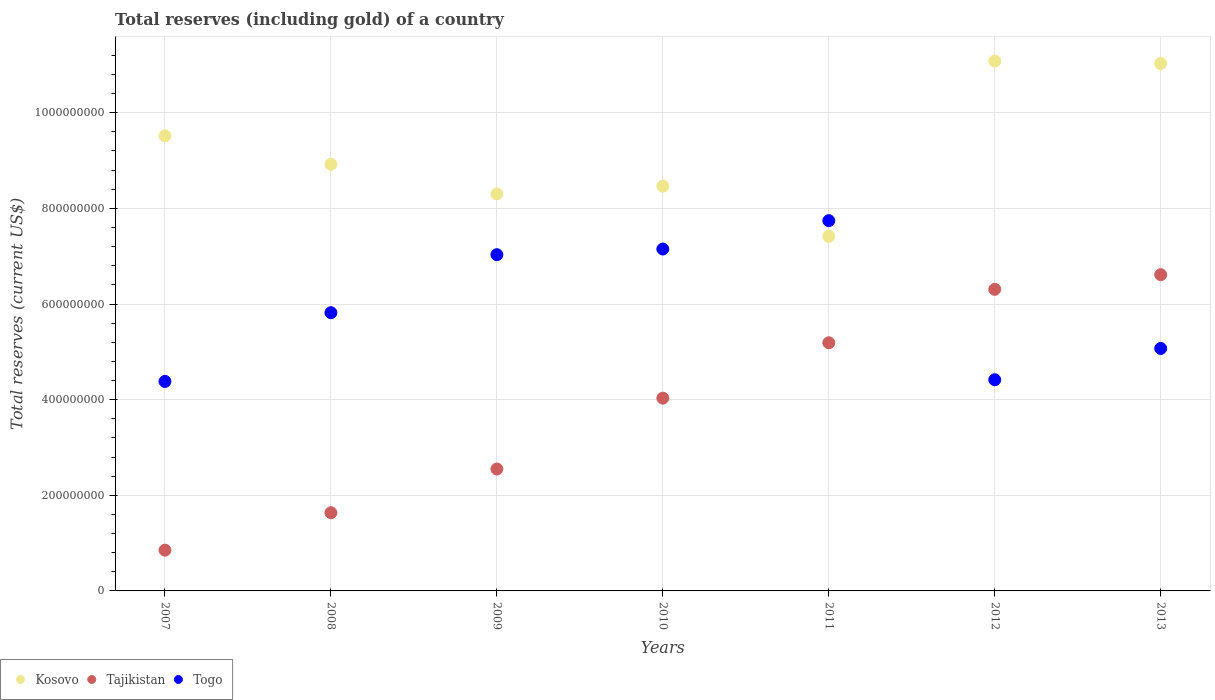How many different coloured dotlines are there?
Your answer should be very brief. 3. What is the total reserves (including gold) in Togo in 2008?
Keep it short and to the point. 5.82e+08. Across all years, what is the maximum total reserves (including gold) in Kosovo?
Ensure brevity in your answer.  1.11e+09. Across all years, what is the minimum total reserves (including gold) in Togo?
Your response must be concise. 4.38e+08. In which year was the total reserves (including gold) in Tajikistan maximum?
Your answer should be compact. 2013. What is the total total reserves (including gold) in Tajikistan in the graph?
Keep it short and to the point. 2.72e+09. What is the difference between the total reserves (including gold) in Tajikistan in 2010 and that in 2013?
Ensure brevity in your answer.  -2.58e+08. What is the difference between the total reserves (including gold) in Kosovo in 2011 and the total reserves (including gold) in Togo in 2010?
Your answer should be very brief. 2.66e+07. What is the average total reserves (including gold) in Togo per year?
Give a very brief answer. 5.94e+08. In the year 2012, what is the difference between the total reserves (including gold) in Kosovo and total reserves (including gold) in Togo?
Your answer should be compact. 6.66e+08. In how many years, is the total reserves (including gold) in Togo greater than 440000000 US$?
Offer a very short reply. 6. What is the ratio of the total reserves (including gold) in Tajikistan in 2008 to that in 2011?
Offer a very short reply. 0.32. Is the total reserves (including gold) in Tajikistan in 2007 less than that in 2011?
Offer a very short reply. Yes. What is the difference between the highest and the second highest total reserves (including gold) in Tajikistan?
Your answer should be compact. 3.06e+07. What is the difference between the highest and the lowest total reserves (including gold) in Tajikistan?
Your answer should be compact. 5.76e+08. Is the sum of the total reserves (including gold) in Kosovo in 2008 and 2009 greater than the maximum total reserves (including gold) in Tajikistan across all years?
Ensure brevity in your answer.  Yes. Is it the case that in every year, the sum of the total reserves (including gold) in Togo and total reserves (including gold) in Tajikistan  is greater than the total reserves (including gold) in Kosovo?
Make the answer very short. No. Does the total reserves (including gold) in Kosovo monotonically increase over the years?
Give a very brief answer. No. Is the total reserves (including gold) in Togo strictly less than the total reserves (including gold) in Kosovo over the years?
Give a very brief answer. No. How many dotlines are there?
Make the answer very short. 3. How many years are there in the graph?
Your answer should be very brief. 7. What is the difference between two consecutive major ticks on the Y-axis?
Ensure brevity in your answer.  2.00e+08. Does the graph contain any zero values?
Offer a terse response. No. Does the graph contain grids?
Ensure brevity in your answer.  Yes. What is the title of the graph?
Offer a terse response. Total reserves (including gold) of a country. What is the label or title of the Y-axis?
Your answer should be compact. Total reserves (current US$). What is the Total reserves (current US$) in Kosovo in 2007?
Ensure brevity in your answer.  9.52e+08. What is the Total reserves (current US$) in Tajikistan in 2007?
Keep it short and to the point. 8.52e+07. What is the Total reserves (current US$) of Togo in 2007?
Keep it short and to the point. 4.38e+08. What is the Total reserves (current US$) in Kosovo in 2008?
Give a very brief answer. 8.92e+08. What is the Total reserves (current US$) in Tajikistan in 2008?
Provide a succinct answer. 1.64e+08. What is the Total reserves (current US$) of Togo in 2008?
Ensure brevity in your answer.  5.82e+08. What is the Total reserves (current US$) in Kosovo in 2009?
Offer a very short reply. 8.30e+08. What is the Total reserves (current US$) of Tajikistan in 2009?
Your answer should be very brief. 2.55e+08. What is the Total reserves (current US$) in Togo in 2009?
Make the answer very short. 7.03e+08. What is the Total reserves (current US$) of Kosovo in 2010?
Offer a terse response. 8.46e+08. What is the Total reserves (current US$) in Tajikistan in 2010?
Provide a succinct answer. 4.03e+08. What is the Total reserves (current US$) of Togo in 2010?
Your answer should be compact. 7.15e+08. What is the Total reserves (current US$) of Kosovo in 2011?
Your response must be concise. 7.42e+08. What is the Total reserves (current US$) in Tajikistan in 2011?
Your response must be concise. 5.19e+08. What is the Total reserves (current US$) in Togo in 2011?
Make the answer very short. 7.74e+08. What is the Total reserves (current US$) in Kosovo in 2012?
Your answer should be very brief. 1.11e+09. What is the Total reserves (current US$) of Tajikistan in 2012?
Provide a succinct answer. 6.31e+08. What is the Total reserves (current US$) of Togo in 2012?
Your answer should be compact. 4.42e+08. What is the Total reserves (current US$) of Kosovo in 2013?
Keep it short and to the point. 1.10e+09. What is the Total reserves (current US$) in Tajikistan in 2013?
Make the answer very short. 6.61e+08. What is the Total reserves (current US$) of Togo in 2013?
Keep it short and to the point. 5.07e+08. Across all years, what is the maximum Total reserves (current US$) in Kosovo?
Make the answer very short. 1.11e+09. Across all years, what is the maximum Total reserves (current US$) in Tajikistan?
Provide a succinct answer. 6.61e+08. Across all years, what is the maximum Total reserves (current US$) of Togo?
Offer a very short reply. 7.74e+08. Across all years, what is the minimum Total reserves (current US$) in Kosovo?
Keep it short and to the point. 7.42e+08. Across all years, what is the minimum Total reserves (current US$) in Tajikistan?
Your answer should be compact. 8.52e+07. Across all years, what is the minimum Total reserves (current US$) of Togo?
Provide a short and direct response. 4.38e+08. What is the total Total reserves (current US$) in Kosovo in the graph?
Your response must be concise. 6.47e+09. What is the total Total reserves (current US$) of Tajikistan in the graph?
Make the answer very short. 2.72e+09. What is the total Total reserves (current US$) of Togo in the graph?
Ensure brevity in your answer.  4.16e+09. What is the difference between the Total reserves (current US$) in Kosovo in 2007 and that in 2008?
Your response must be concise. 5.97e+07. What is the difference between the Total reserves (current US$) in Tajikistan in 2007 and that in 2008?
Keep it short and to the point. -7.83e+07. What is the difference between the Total reserves (current US$) in Togo in 2007 and that in 2008?
Make the answer very short. -1.44e+08. What is the difference between the Total reserves (current US$) of Kosovo in 2007 and that in 2009?
Your response must be concise. 1.22e+08. What is the difference between the Total reserves (current US$) of Tajikistan in 2007 and that in 2009?
Your response must be concise. -1.70e+08. What is the difference between the Total reserves (current US$) in Togo in 2007 and that in 2009?
Your answer should be very brief. -2.65e+08. What is the difference between the Total reserves (current US$) in Kosovo in 2007 and that in 2010?
Make the answer very short. 1.05e+08. What is the difference between the Total reserves (current US$) in Tajikistan in 2007 and that in 2010?
Offer a terse response. -3.18e+08. What is the difference between the Total reserves (current US$) of Togo in 2007 and that in 2010?
Your answer should be compact. -2.77e+08. What is the difference between the Total reserves (current US$) of Kosovo in 2007 and that in 2011?
Give a very brief answer. 2.10e+08. What is the difference between the Total reserves (current US$) in Tajikistan in 2007 and that in 2011?
Keep it short and to the point. -4.34e+08. What is the difference between the Total reserves (current US$) in Togo in 2007 and that in 2011?
Provide a succinct answer. -3.36e+08. What is the difference between the Total reserves (current US$) of Kosovo in 2007 and that in 2012?
Offer a very short reply. -1.56e+08. What is the difference between the Total reserves (current US$) of Tajikistan in 2007 and that in 2012?
Ensure brevity in your answer.  -5.45e+08. What is the difference between the Total reserves (current US$) of Togo in 2007 and that in 2012?
Offer a terse response. -3.51e+06. What is the difference between the Total reserves (current US$) of Kosovo in 2007 and that in 2013?
Your response must be concise. -1.51e+08. What is the difference between the Total reserves (current US$) in Tajikistan in 2007 and that in 2013?
Give a very brief answer. -5.76e+08. What is the difference between the Total reserves (current US$) of Togo in 2007 and that in 2013?
Your answer should be very brief. -6.90e+07. What is the difference between the Total reserves (current US$) of Kosovo in 2008 and that in 2009?
Provide a succinct answer. 6.19e+07. What is the difference between the Total reserves (current US$) of Tajikistan in 2008 and that in 2009?
Your response must be concise. -9.14e+07. What is the difference between the Total reserves (current US$) of Togo in 2008 and that in 2009?
Your answer should be compact. -1.21e+08. What is the difference between the Total reserves (current US$) in Kosovo in 2008 and that in 2010?
Make the answer very short. 4.57e+07. What is the difference between the Total reserves (current US$) of Tajikistan in 2008 and that in 2010?
Offer a terse response. -2.40e+08. What is the difference between the Total reserves (current US$) in Togo in 2008 and that in 2010?
Offer a terse response. -1.33e+08. What is the difference between the Total reserves (current US$) in Kosovo in 2008 and that in 2011?
Make the answer very short. 1.51e+08. What is the difference between the Total reserves (current US$) in Tajikistan in 2008 and that in 2011?
Ensure brevity in your answer.  -3.55e+08. What is the difference between the Total reserves (current US$) in Togo in 2008 and that in 2011?
Your answer should be compact. -1.92e+08. What is the difference between the Total reserves (current US$) of Kosovo in 2008 and that in 2012?
Give a very brief answer. -2.16e+08. What is the difference between the Total reserves (current US$) in Tajikistan in 2008 and that in 2012?
Make the answer very short. -4.67e+08. What is the difference between the Total reserves (current US$) of Togo in 2008 and that in 2012?
Your answer should be very brief. 1.40e+08. What is the difference between the Total reserves (current US$) in Kosovo in 2008 and that in 2013?
Provide a succinct answer. -2.11e+08. What is the difference between the Total reserves (current US$) of Tajikistan in 2008 and that in 2013?
Provide a short and direct response. -4.98e+08. What is the difference between the Total reserves (current US$) in Togo in 2008 and that in 2013?
Provide a short and direct response. 7.48e+07. What is the difference between the Total reserves (current US$) in Kosovo in 2009 and that in 2010?
Your answer should be very brief. -1.62e+07. What is the difference between the Total reserves (current US$) of Tajikistan in 2009 and that in 2010?
Make the answer very short. -1.48e+08. What is the difference between the Total reserves (current US$) of Togo in 2009 and that in 2010?
Make the answer very short. -1.18e+07. What is the difference between the Total reserves (current US$) in Kosovo in 2009 and that in 2011?
Provide a succinct answer. 8.87e+07. What is the difference between the Total reserves (current US$) in Tajikistan in 2009 and that in 2011?
Keep it short and to the point. -2.64e+08. What is the difference between the Total reserves (current US$) of Togo in 2009 and that in 2011?
Ensure brevity in your answer.  -7.11e+07. What is the difference between the Total reserves (current US$) of Kosovo in 2009 and that in 2012?
Make the answer very short. -2.78e+08. What is the difference between the Total reserves (current US$) of Tajikistan in 2009 and that in 2012?
Your response must be concise. -3.76e+08. What is the difference between the Total reserves (current US$) of Togo in 2009 and that in 2012?
Offer a very short reply. 2.62e+08. What is the difference between the Total reserves (current US$) in Kosovo in 2009 and that in 2013?
Ensure brevity in your answer.  -2.73e+08. What is the difference between the Total reserves (current US$) of Tajikistan in 2009 and that in 2013?
Offer a very short reply. -4.06e+08. What is the difference between the Total reserves (current US$) of Togo in 2009 and that in 2013?
Provide a short and direct response. 1.96e+08. What is the difference between the Total reserves (current US$) of Kosovo in 2010 and that in 2011?
Offer a terse response. 1.05e+08. What is the difference between the Total reserves (current US$) of Tajikistan in 2010 and that in 2011?
Your answer should be very brief. -1.16e+08. What is the difference between the Total reserves (current US$) in Togo in 2010 and that in 2011?
Give a very brief answer. -5.94e+07. What is the difference between the Total reserves (current US$) of Kosovo in 2010 and that in 2012?
Ensure brevity in your answer.  -2.62e+08. What is the difference between the Total reserves (current US$) of Tajikistan in 2010 and that in 2012?
Your answer should be compact. -2.28e+08. What is the difference between the Total reserves (current US$) of Togo in 2010 and that in 2012?
Offer a very short reply. 2.73e+08. What is the difference between the Total reserves (current US$) of Kosovo in 2010 and that in 2013?
Your answer should be very brief. -2.57e+08. What is the difference between the Total reserves (current US$) in Tajikistan in 2010 and that in 2013?
Offer a very short reply. -2.58e+08. What is the difference between the Total reserves (current US$) of Togo in 2010 and that in 2013?
Ensure brevity in your answer.  2.08e+08. What is the difference between the Total reserves (current US$) in Kosovo in 2011 and that in 2012?
Your response must be concise. -3.67e+08. What is the difference between the Total reserves (current US$) of Tajikistan in 2011 and that in 2012?
Make the answer very short. -1.12e+08. What is the difference between the Total reserves (current US$) of Togo in 2011 and that in 2012?
Ensure brevity in your answer.  3.33e+08. What is the difference between the Total reserves (current US$) in Kosovo in 2011 and that in 2013?
Offer a very short reply. -3.61e+08. What is the difference between the Total reserves (current US$) of Tajikistan in 2011 and that in 2013?
Provide a succinct answer. -1.42e+08. What is the difference between the Total reserves (current US$) of Togo in 2011 and that in 2013?
Provide a succinct answer. 2.67e+08. What is the difference between the Total reserves (current US$) of Kosovo in 2012 and that in 2013?
Your answer should be compact. 5.18e+06. What is the difference between the Total reserves (current US$) in Tajikistan in 2012 and that in 2013?
Make the answer very short. -3.06e+07. What is the difference between the Total reserves (current US$) of Togo in 2012 and that in 2013?
Make the answer very short. -6.55e+07. What is the difference between the Total reserves (current US$) of Kosovo in 2007 and the Total reserves (current US$) of Tajikistan in 2008?
Offer a terse response. 7.88e+08. What is the difference between the Total reserves (current US$) in Kosovo in 2007 and the Total reserves (current US$) in Togo in 2008?
Your response must be concise. 3.70e+08. What is the difference between the Total reserves (current US$) of Tajikistan in 2007 and the Total reserves (current US$) of Togo in 2008?
Provide a short and direct response. -4.97e+08. What is the difference between the Total reserves (current US$) in Kosovo in 2007 and the Total reserves (current US$) in Tajikistan in 2009?
Make the answer very short. 6.97e+08. What is the difference between the Total reserves (current US$) in Kosovo in 2007 and the Total reserves (current US$) in Togo in 2009?
Offer a terse response. 2.49e+08. What is the difference between the Total reserves (current US$) in Tajikistan in 2007 and the Total reserves (current US$) in Togo in 2009?
Your response must be concise. -6.18e+08. What is the difference between the Total reserves (current US$) in Kosovo in 2007 and the Total reserves (current US$) in Tajikistan in 2010?
Make the answer very short. 5.49e+08. What is the difference between the Total reserves (current US$) of Kosovo in 2007 and the Total reserves (current US$) of Togo in 2010?
Keep it short and to the point. 2.37e+08. What is the difference between the Total reserves (current US$) in Tajikistan in 2007 and the Total reserves (current US$) in Togo in 2010?
Your response must be concise. -6.30e+08. What is the difference between the Total reserves (current US$) in Kosovo in 2007 and the Total reserves (current US$) in Tajikistan in 2011?
Your answer should be compact. 4.33e+08. What is the difference between the Total reserves (current US$) of Kosovo in 2007 and the Total reserves (current US$) of Togo in 2011?
Keep it short and to the point. 1.77e+08. What is the difference between the Total reserves (current US$) of Tajikistan in 2007 and the Total reserves (current US$) of Togo in 2011?
Offer a very short reply. -6.89e+08. What is the difference between the Total reserves (current US$) of Kosovo in 2007 and the Total reserves (current US$) of Tajikistan in 2012?
Offer a terse response. 3.21e+08. What is the difference between the Total reserves (current US$) of Kosovo in 2007 and the Total reserves (current US$) of Togo in 2012?
Give a very brief answer. 5.10e+08. What is the difference between the Total reserves (current US$) of Tajikistan in 2007 and the Total reserves (current US$) of Togo in 2012?
Your answer should be compact. -3.56e+08. What is the difference between the Total reserves (current US$) in Kosovo in 2007 and the Total reserves (current US$) in Tajikistan in 2013?
Your answer should be compact. 2.90e+08. What is the difference between the Total reserves (current US$) in Kosovo in 2007 and the Total reserves (current US$) in Togo in 2013?
Provide a succinct answer. 4.45e+08. What is the difference between the Total reserves (current US$) of Tajikistan in 2007 and the Total reserves (current US$) of Togo in 2013?
Your answer should be very brief. -4.22e+08. What is the difference between the Total reserves (current US$) in Kosovo in 2008 and the Total reserves (current US$) in Tajikistan in 2009?
Your answer should be very brief. 6.37e+08. What is the difference between the Total reserves (current US$) in Kosovo in 2008 and the Total reserves (current US$) in Togo in 2009?
Your answer should be very brief. 1.89e+08. What is the difference between the Total reserves (current US$) of Tajikistan in 2008 and the Total reserves (current US$) of Togo in 2009?
Give a very brief answer. -5.40e+08. What is the difference between the Total reserves (current US$) of Kosovo in 2008 and the Total reserves (current US$) of Tajikistan in 2010?
Offer a very short reply. 4.89e+08. What is the difference between the Total reserves (current US$) of Kosovo in 2008 and the Total reserves (current US$) of Togo in 2010?
Give a very brief answer. 1.77e+08. What is the difference between the Total reserves (current US$) of Tajikistan in 2008 and the Total reserves (current US$) of Togo in 2010?
Offer a very short reply. -5.51e+08. What is the difference between the Total reserves (current US$) of Kosovo in 2008 and the Total reserves (current US$) of Tajikistan in 2011?
Give a very brief answer. 3.73e+08. What is the difference between the Total reserves (current US$) of Kosovo in 2008 and the Total reserves (current US$) of Togo in 2011?
Your answer should be compact. 1.18e+08. What is the difference between the Total reserves (current US$) in Tajikistan in 2008 and the Total reserves (current US$) in Togo in 2011?
Give a very brief answer. -6.11e+08. What is the difference between the Total reserves (current US$) of Kosovo in 2008 and the Total reserves (current US$) of Tajikistan in 2012?
Keep it short and to the point. 2.61e+08. What is the difference between the Total reserves (current US$) of Kosovo in 2008 and the Total reserves (current US$) of Togo in 2012?
Offer a very short reply. 4.50e+08. What is the difference between the Total reserves (current US$) in Tajikistan in 2008 and the Total reserves (current US$) in Togo in 2012?
Offer a very short reply. -2.78e+08. What is the difference between the Total reserves (current US$) in Kosovo in 2008 and the Total reserves (current US$) in Tajikistan in 2013?
Your response must be concise. 2.31e+08. What is the difference between the Total reserves (current US$) of Kosovo in 2008 and the Total reserves (current US$) of Togo in 2013?
Give a very brief answer. 3.85e+08. What is the difference between the Total reserves (current US$) of Tajikistan in 2008 and the Total reserves (current US$) of Togo in 2013?
Give a very brief answer. -3.44e+08. What is the difference between the Total reserves (current US$) in Kosovo in 2009 and the Total reserves (current US$) in Tajikistan in 2010?
Give a very brief answer. 4.27e+08. What is the difference between the Total reserves (current US$) of Kosovo in 2009 and the Total reserves (current US$) of Togo in 2010?
Your answer should be very brief. 1.15e+08. What is the difference between the Total reserves (current US$) of Tajikistan in 2009 and the Total reserves (current US$) of Togo in 2010?
Your answer should be very brief. -4.60e+08. What is the difference between the Total reserves (current US$) of Kosovo in 2009 and the Total reserves (current US$) of Tajikistan in 2011?
Ensure brevity in your answer.  3.11e+08. What is the difference between the Total reserves (current US$) of Kosovo in 2009 and the Total reserves (current US$) of Togo in 2011?
Provide a short and direct response. 5.59e+07. What is the difference between the Total reserves (current US$) of Tajikistan in 2009 and the Total reserves (current US$) of Togo in 2011?
Keep it short and to the point. -5.19e+08. What is the difference between the Total reserves (current US$) of Kosovo in 2009 and the Total reserves (current US$) of Tajikistan in 2012?
Keep it short and to the point. 2.00e+08. What is the difference between the Total reserves (current US$) of Kosovo in 2009 and the Total reserves (current US$) of Togo in 2012?
Make the answer very short. 3.89e+08. What is the difference between the Total reserves (current US$) in Tajikistan in 2009 and the Total reserves (current US$) in Togo in 2012?
Your response must be concise. -1.87e+08. What is the difference between the Total reserves (current US$) in Kosovo in 2009 and the Total reserves (current US$) in Tajikistan in 2013?
Provide a succinct answer. 1.69e+08. What is the difference between the Total reserves (current US$) of Kosovo in 2009 and the Total reserves (current US$) of Togo in 2013?
Make the answer very short. 3.23e+08. What is the difference between the Total reserves (current US$) in Tajikistan in 2009 and the Total reserves (current US$) in Togo in 2013?
Your answer should be compact. -2.52e+08. What is the difference between the Total reserves (current US$) of Kosovo in 2010 and the Total reserves (current US$) of Tajikistan in 2011?
Your answer should be very brief. 3.27e+08. What is the difference between the Total reserves (current US$) of Kosovo in 2010 and the Total reserves (current US$) of Togo in 2011?
Keep it short and to the point. 7.21e+07. What is the difference between the Total reserves (current US$) in Tajikistan in 2010 and the Total reserves (current US$) in Togo in 2011?
Offer a very short reply. -3.71e+08. What is the difference between the Total reserves (current US$) of Kosovo in 2010 and the Total reserves (current US$) of Tajikistan in 2012?
Keep it short and to the point. 2.16e+08. What is the difference between the Total reserves (current US$) of Kosovo in 2010 and the Total reserves (current US$) of Togo in 2012?
Your response must be concise. 4.05e+08. What is the difference between the Total reserves (current US$) in Tajikistan in 2010 and the Total reserves (current US$) in Togo in 2012?
Ensure brevity in your answer.  -3.85e+07. What is the difference between the Total reserves (current US$) of Kosovo in 2010 and the Total reserves (current US$) of Tajikistan in 2013?
Your response must be concise. 1.85e+08. What is the difference between the Total reserves (current US$) of Kosovo in 2010 and the Total reserves (current US$) of Togo in 2013?
Offer a terse response. 3.39e+08. What is the difference between the Total reserves (current US$) in Tajikistan in 2010 and the Total reserves (current US$) in Togo in 2013?
Your answer should be compact. -1.04e+08. What is the difference between the Total reserves (current US$) in Kosovo in 2011 and the Total reserves (current US$) in Tajikistan in 2012?
Provide a short and direct response. 1.11e+08. What is the difference between the Total reserves (current US$) in Kosovo in 2011 and the Total reserves (current US$) in Togo in 2012?
Provide a short and direct response. 3.00e+08. What is the difference between the Total reserves (current US$) in Tajikistan in 2011 and the Total reserves (current US$) in Togo in 2012?
Offer a very short reply. 7.73e+07. What is the difference between the Total reserves (current US$) in Kosovo in 2011 and the Total reserves (current US$) in Tajikistan in 2013?
Give a very brief answer. 8.02e+07. What is the difference between the Total reserves (current US$) of Kosovo in 2011 and the Total reserves (current US$) of Togo in 2013?
Keep it short and to the point. 2.34e+08. What is the difference between the Total reserves (current US$) of Tajikistan in 2011 and the Total reserves (current US$) of Togo in 2013?
Keep it short and to the point. 1.19e+07. What is the difference between the Total reserves (current US$) of Kosovo in 2012 and the Total reserves (current US$) of Tajikistan in 2013?
Provide a succinct answer. 4.47e+08. What is the difference between the Total reserves (current US$) of Kosovo in 2012 and the Total reserves (current US$) of Togo in 2013?
Ensure brevity in your answer.  6.01e+08. What is the difference between the Total reserves (current US$) of Tajikistan in 2012 and the Total reserves (current US$) of Togo in 2013?
Your response must be concise. 1.24e+08. What is the average Total reserves (current US$) of Kosovo per year?
Offer a very short reply. 9.25e+08. What is the average Total reserves (current US$) of Tajikistan per year?
Ensure brevity in your answer.  3.88e+08. What is the average Total reserves (current US$) of Togo per year?
Provide a succinct answer. 5.94e+08. In the year 2007, what is the difference between the Total reserves (current US$) of Kosovo and Total reserves (current US$) of Tajikistan?
Your response must be concise. 8.67e+08. In the year 2007, what is the difference between the Total reserves (current US$) of Kosovo and Total reserves (current US$) of Togo?
Ensure brevity in your answer.  5.14e+08. In the year 2007, what is the difference between the Total reserves (current US$) of Tajikistan and Total reserves (current US$) of Togo?
Make the answer very short. -3.53e+08. In the year 2008, what is the difference between the Total reserves (current US$) in Kosovo and Total reserves (current US$) in Tajikistan?
Provide a short and direct response. 7.29e+08. In the year 2008, what is the difference between the Total reserves (current US$) of Kosovo and Total reserves (current US$) of Togo?
Give a very brief answer. 3.10e+08. In the year 2008, what is the difference between the Total reserves (current US$) of Tajikistan and Total reserves (current US$) of Togo?
Offer a very short reply. -4.18e+08. In the year 2009, what is the difference between the Total reserves (current US$) of Kosovo and Total reserves (current US$) of Tajikistan?
Your response must be concise. 5.75e+08. In the year 2009, what is the difference between the Total reserves (current US$) in Kosovo and Total reserves (current US$) in Togo?
Provide a short and direct response. 1.27e+08. In the year 2009, what is the difference between the Total reserves (current US$) in Tajikistan and Total reserves (current US$) in Togo?
Offer a terse response. -4.48e+08. In the year 2010, what is the difference between the Total reserves (current US$) of Kosovo and Total reserves (current US$) of Tajikistan?
Offer a terse response. 4.43e+08. In the year 2010, what is the difference between the Total reserves (current US$) in Kosovo and Total reserves (current US$) in Togo?
Offer a very short reply. 1.31e+08. In the year 2010, what is the difference between the Total reserves (current US$) of Tajikistan and Total reserves (current US$) of Togo?
Your response must be concise. -3.12e+08. In the year 2011, what is the difference between the Total reserves (current US$) in Kosovo and Total reserves (current US$) in Tajikistan?
Your response must be concise. 2.23e+08. In the year 2011, what is the difference between the Total reserves (current US$) of Kosovo and Total reserves (current US$) of Togo?
Make the answer very short. -3.28e+07. In the year 2011, what is the difference between the Total reserves (current US$) of Tajikistan and Total reserves (current US$) of Togo?
Your answer should be compact. -2.55e+08. In the year 2012, what is the difference between the Total reserves (current US$) of Kosovo and Total reserves (current US$) of Tajikistan?
Give a very brief answer. 4.77e+08. In the year 2012, what is the difference between the Total reserves (current US$) in Kosovo and Total reserves (current US$) in Togo?
Ensure brevity in your answer.  6.66e+08. In the year 2012, what is the difference between the Total reserves (current US$) of Tajikistan and Total reserves (current US$) of Togo?
Keep it short and to the point. 1.89e+08. In the year 2013, what is the difference between the Total reserves (current US$) of Kosovo and Total reserves (current US$) of Tajikistan?
Your response must be concise. 4.42e+08. In the year 2013, what is the difference between the Total reserves (current US$) in Kosovo and Total reserves (current US$) in Togo?
Make the answer very short. 5.96e+08. In the year 2013, what is the difference between the Total reserves (current US$) in Tajikistan and Total reserves (current US$) in Togo?
Your answer should be very brief. 1.54e+08. What is the ratio of the Total reserves (current US$) in Kosovo in 2007 to that in 2008?
Provide a short and direct response. 1.07. What is the ratio of the Total reserves (current US$) of Tajikistan in 2007 to that in 2008?
Your response must be concise. 0.52. What is the ratio of the Total reserves (current US$) in Togo in 2007 to that in 2008?
Offer a terse response. 0.75. What is the ratio of the Total reserves (current US$) of Kosovo in 2007 to that in 2009?
Make the answer very short. 1.15. What is the ratio of the Total reserves (current US$) in Tajikistan in 2007 to that in 2009?
Offer a very short reply. 0.33. What is the ratio of the Total reserves (current US$) of Togo in 2007 to that in 2009?
Offer a very short reply. 0.62. What is the ratio of the Total reserves (current US$) of Kosovo in 2007 to that in 2010?
Your answer should be very brief. 1.12. What is the ratio of the Total reserves (current US$) of Tajikistan in 2007 to that in 2010?
Provide a succinct answer. 0.21. What is the ratio of the Total reserves (current US$) of Togo in 2007 to that in 2010?
Your response must be concise. 0.61. What is the ratio of the Total reserves (current US$) in Kosovo in 2007 to that in 2011?
Provide a succinct answer. 1.28. What is the ratio of the Total reserves (current US$) in Tajikistan in 2007 to that in 2011?
Keep it short and to the point. 0.16. What is the ratio of the Total reserves (current US$) in Togo in 2007 to that in 2011?
Make the answer very short. 0.57. What is the ratio of the Total reserves (current US$) in Kosovo in 2007 to that in 2012?
Your answer should be compact. 0.86. What is the ratio of the Total reserves (current US$) of Tajikistan in 2007 to that in 2012?
Provide a short and direct response. 0.14. What is the ratio of the Total reserves (current US$) of Kosovo in 2007 to that in 2013?
Provide a short and direct response. 0.86. What is the ratio of the Total reserves (current US$) of Tajikistan in 2007 to that in 2013?
Your response must be concise. 0.13. What is the ratio of the Total reserves (current US$) of Togo in 2007 to that in 2013?
Make the answer very short. 0.86. What is the ratio of the Total reserves (current US$) of Kosovo in 2008 to that in 2009?
Your answer should be compact. 1.07. What is the ratio of the Total reserves (current US$) in Tajikistan in 2008 to that in 2009?
Your answer should be compact. 0.64. What is the ratio of the Total reserves (current US$) in Togo in 2008 to that in 2009?
Ensure brevity in your answer.  0.83. What is the ratio of the Total reserves (current US$) of Kosovo in 2008 to that in 2010?
Ensure brevity in your answer.  1.05. What is the ratio of the Total reserves (current US$) of Tajikistan in 2008 to that in 2010?
Your answer should be compact. 0.41. What is the ratio of the Total reserves (current US$) in Togo in 2008 to that in 2010?
Give a very brief answer. 0.81. What is the ratio of the Total reserves (current US$) of Kosovo in 2008 to that in 2011?
Offer a very short reply. 1.2. What is the ratio of the Total reserves (current US$) of Tajikistan in 2008 to that in 2011?
Your answer should be compact. 0.32. What is the ratio of the Total reserves (current US$) in Togo in 2008 to that in 2011?
Give a very brief answer. 0.75. What is the ratio of the Total reserves (current US$) in Kosovo in 2008 to that in 2012?
Your response must be concise. 0.81. What is the ratio of the Total reserves (current US$) in Tajikistan in 2008 to that in 2012?
Make the answer very short. 0.26. What is the ratio of the Total reserves (current US$) in Togo in 2008 to that in 2012?
Make the answer very short. 1.32. What is the ratio of the Total reserves (current US$) in Kosovo in 2008 to that in 2013?
Your response must be concise. 0.81. What is the ratio of the Total reserves (current US$) of Tajikistan in 2008 to that in 2013?
Your answer should be compact. 0.25. What is the ratio of the Total reserves (current US$) in Togo in 2008 to that in 2013?
Make the answer very short. 1.15. What is the ratio of the Total reserves (current US$) in Kosovo in 2009 to that in 2010?
Keep it short and to the point. 0.98. What is the ratio of the Total reserves (current US$) of Tajikistan in 2009 to that in 2010?
Provide a succinct answer. 0.63. What is the ratio of the Total reserves (current US$) of Togo in 2009 to that in 2010?
Your response must be concise. 0.98. What is the ratio of the Total reserves (current US$) of Kosovo in 2009 to that in 2011?
Give a very brief answer. 1.12. What is the ratio of the Total reserves (current US$) of Tajikistan in 2009 to that in 2011?
Provide a succinct answer. 0.49. What is the ratio of the Total reserves (current US$) of Togo in 2009 to that in 2011?
Your answer should be very brief. 0.91. What is the ratio of the Total reserves (current US$) of Kosovo in 2009 to that in 2012?
Provide a succinct answer. 0.75. What is the ratio of the Total reserves (current US$) of Tajikistan in 2009 to that in 2012?
Give a very brief answer. 0.4. What is the ratio of the Total reserves (current US$) of Togo in 2009 to that in 2012?
Provide a succinct answer. 1.59. What is the ratio of the Total reserves (current US$) of Kosovo in 2009 to that in 2013?
Make the answer very short. 0.75. What is the ratio of the Total reserves (current US$) of Tajikistan in 2009 to that in 2013?
Your answer should be very brief. 0.39. What is the ratio of the Total reserves (current US$) in Togo in 2009 to that in 2013?
Keep it short and to the point. 1.39. What is the ratio of the Total reserves (current US$) in Kosovo in 2010 to that in 2011?
Give a very brief answer. 1.14. What is the ratio of the Total reserves (current US$) in Tajikistan in 2010 to that in 2011?
Offer a terse response. 0.78. What is the ratio of the Total reserves (current US$) of Togo in 2010 to that in 2011?
Offer a terse response. 0.92. What is the ratio of the Total reserves (current US$) of Kosovo in 2010 to that in 2012?
Keep it short and to the point. 0.76. What is the ratio of the Total reserves (current US$) in Tajikistan in 2010 to that in 2012?
Provide a short and direct response. 0.64. What is the ratio of the Total reserves (current US$) of Togo in 2010 to that in 2012?
Provide a short and direct response. 1.62. What is the ratio of the Total reserves (current US$) in Kosovo in 2010 to that in 2013?
Your response must be concise. 0.77. What is the ratio of the Total reserves (current US$) of Tajikistan in 2010 to that in 2013?
Ensure brevity in your answer.  0.61. What is the ratio of the Total reserves (current US$) of Togo in 2010 to that in 2013?
Your response must be concise. 1.41. What is the ratio of the Total reserves (current US$) of Kosovo in 2011 to that in 2012?
Make the answer very short. 0.67. What is the ratio of the Total reserves (current US$) of Tajikistan in 2011 to that in 2012?
Offer a very short reply. 0.82. What is the ratio of the Total reserves (current US$) of Togo in 2011 to that in 2012?
Offer a very short reply. 1.75. What is the ratio of the Total reserves (current US$) in Kosovo in 2011 to that in 2013?
Give a very brief answer. 0.67. What is the ratio of the Total reserves (current US$) of Tajikistan in 2011 to that in 2013?
Your answer should be very brief. 0.78. What is the ratio of the Total reserves (current US$) of Togo in 2011 to that in 2013?
Keep it short and to the point. 1.53. What is the ratio of the Total reserves (current US$) in Tajikistan in 2012 to that in 2013?
Ensure brevity in your answer.  0.95. What is the ratio of the Total reserves (current US$) in Togo in 2012 to that in 2013?
Provide a succinct answer. 0.87. What is the difference between the highest and the second highest Total reserves (current US$) in Kosovo?
Your answer should be very brief. 5.18e+06. What is the difference between the highest and the second highest Total reserves (current US$) of Tajikistan?
Your answer should be very brief. 3.06e+07. What is the difference between the highest and the second highest Total reserves (current US$) in Togo?
Your response must be concise. 5.94e+07. What is the difference between the highest and the lowest Total reserves (current US$) of Kosovo?
Provide a succinct answer. 3.67e+08. What is the difference between the highest and the lowest Total reserves (current US$) of Tajikistan?
Keep it short and to the point. 5.76e+08. What is the difference between the highest and the lowest Total reserves (current US$) of Togo?
Offer a very short reply. 3.36e+08. 